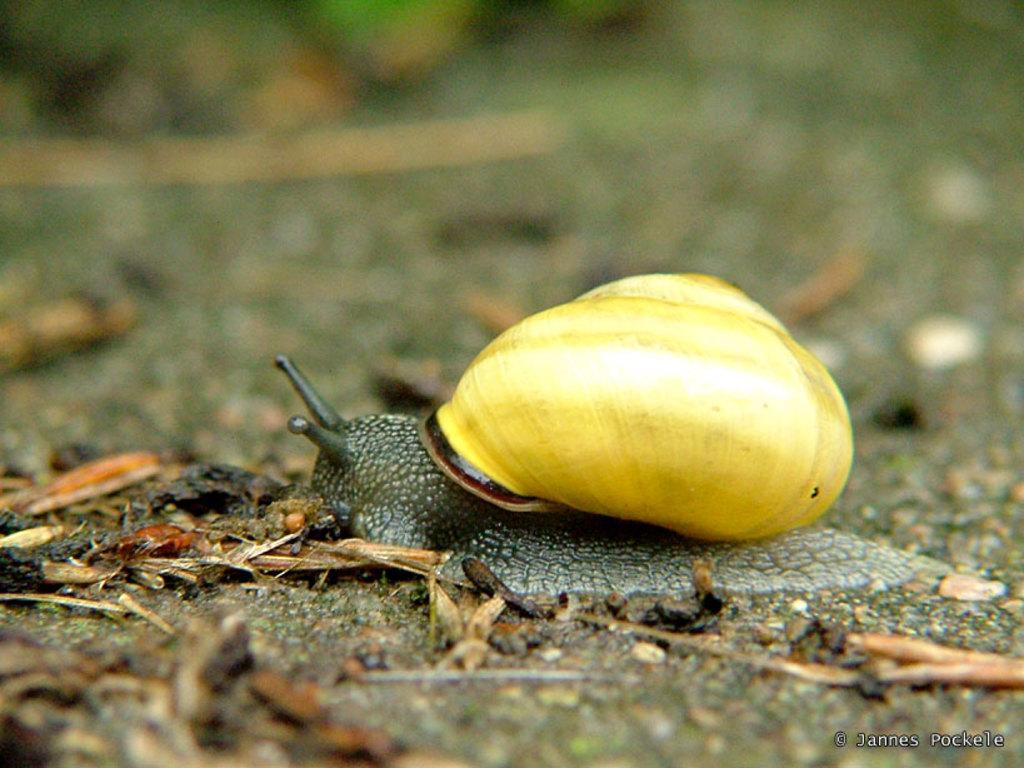In one or two sentences, can you explain what this image depicts? In this image I can see a snail, the background is blurred. 